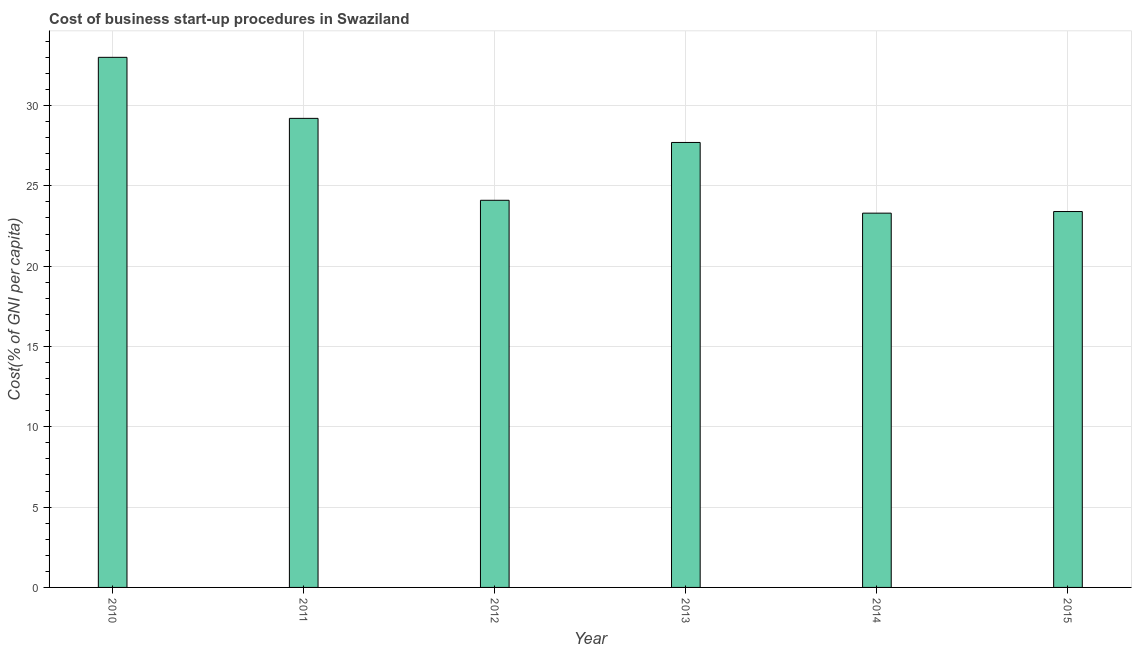Does the graph contain any zero values?
Offer a very short reply. No. What is the title of the graph?
Provide a short and direct response. Cost of business start-up procedures in Swaziland. What is the label or title of the X-axis?
Keep it short and to the point. Year. What is the label or title of the Y-axis?
Provide a succinct answer. Cost(% of GNI per capita). What is the cost of business startup procedures in 2011?
Provide a short and direct response. 29.2. Across all years, what is the maximum cost of business startup procedures?
Offer a very short reply. 33. Across all years, what is the minimum cost of business startup procedures?
Provide a succinct answer. 23.3. In which year was the cost of business startup procedures minimum?
Your answer should be very brief. 2014. What is the sum of the cost of business startup procedures?
Your response must be concise. 160.7. What is the average cost of business startup procedures per year?
Your response must be concise. 26.78. What is the median cost of business startup procedures?
Give a very brief answer. 25.9. What is the ratio of the cost of business startup procedures in 2011 to that in 2014?
Give a very brief answer. 1.25. What is the difference between the highest and the second highest cost of business startup procedures?
Your answer should be compact. 3.8. Is the sum of the cost of business startup procedures in 2010 and 2013 greater than the maximum cost of business startup procedures across all years?
Give a very brief answer. Yes. In how many years, is the cost of business startup procedures greater than the average cost of business startup procedures taken over all years?
Ensure brevity in your answer.  3. How many bars are there?
Provide a short and direct response. 6. Are all the bars in the graph horizontal?
Your answer should be very brief. No. How many years are there in the graph?
Make the answer very short. 6. What is the difference between two consecutive major ticks on the Y-axis?
Provide a succinct answer. 5. Are the values on the major ticks of Y-axis written in scientific E-notation?
Make the answer very short. No. What is the Cost(% of GNI per capita) in 2011?
Your response must be concise. 29.2. What is the Cost(% of GNI per capita) in 2012?
Provide a succinct answer. 24.1. What is the Cost(% of GNI per capita) of 2013?
Offer a very short reply. 27.7. What is the Cost(% of GNI per capita) in 2014?
Your response must be concise. 23.3. What is the Cost(% of GNI per capita) of 2015?
Keep it short and to the point. 23.4. What is the difference between the Cost(% of GNI per capita) in 2010 and 2011?
Your response must be concise. 3.8. What is the difference between the Cost(% of GNI per capita) in 2011 and 2012?
Ensure brevity in your answer.  5.1. What is the difference between the Cost(% of GNI per capita) in 2012 and 2014?
Your answer should be compact. 0.8. What is the difference between the Cost(% of GNI per capita) in 2013 and 2015?
Make the answer very short. 4.3. What is the ratio of the Cost(% of GNI per capita) in 2010 to that in 2011?
Give a very brief answer. 1.13. What is the ratio of the Cost(% of GNI per capita) in 2010 to that in 2012?
Keep it short and to the point. 1.37. What is the ratio of the Cost(% of GNI per capita) in 2010 to that in 2013?
Provide a short and direct response. 1.19. What is the ratio of the Cost(% of GNI per capita) in 2010 to that in 2014?
Your answer should be very brief. 1.42. What is the ratio of the Cost(% of GNI per capita) in 2010 to that in 2015?
Provide a succinct answer. 1.41. What is the ratio of the Cost(% of GNI per capita) in 2011 to that in 2012?
Provide a succinct answer. 1.21. What is the ratio of the Cost(% of GNI per capita) in 2011 to that in 2013?
Provide a succinct answer. 1.05. What is the ratio of the Cost(% of GNI per capita) in 2011 to that in 2014?
Provide a succinct answer. 1.25. What is the ratio of the Cost(% of GNI per capita) in 2011 to that in 2015?
Provide a succinct answer. 1.25. What is the ratio of the Cost(% of GNI per capita) in 2012 to that in 2013?
Ensure brevity in your answer.  0.87. What is the ratio of the Cost(% of GNI per capita) in 2012 to that in 2014?
Provide a short and direct response. 1.03. What is the ratio of the Cost(% of GNI per capita) in 2012 to that in 2015?
Ensure brevity in your answer.  1.03. What is the ratio of the Cost(% of GNI per capita) in 2013 to that in 2014?
Make the answer very short. 1.19. What is the ratio of the Cost(% of GNI per capita) in 2013 to that in 2015?
Your answer should be very brief. 1.18. What is the ratio of the Cost(% of GNI per capita) in 2014 to that in 2015?
Offer a terse response. 1. 